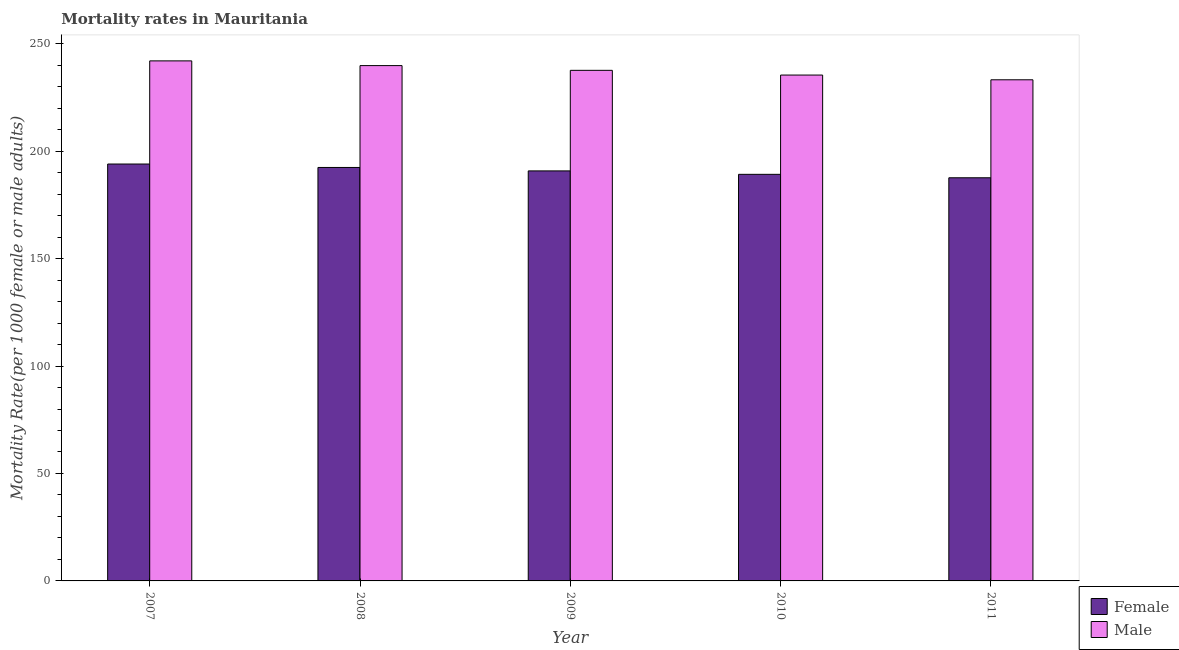How many groups of bars are there?
Offer a very short reply. 5. Are the number of bars per tick equal to the number of legend labels?
Keep it short and to the point. Yes. Are the number of bars on each tick of the X-axis equal?
Your answer should be compact. Yes. How many bars are there on the 1st tick from the left?
Provide a succinct answer. 2. How many bars are there on the 3rd tick from the right?
Ensure brevity in your answer.  2. What is the label of the 2nd group of bars from the left?
Give a very brief answer. 2008. What is the female mortality rate in 2011?
Ensure brevity in your answer.  187.6. Across all years, what is the maximum male mortality rate?
Offer a very short reply. 242. Across all years, what is the minimum male mortality rate?
Your answer should be very brief. 233.2. What is the total male mortality rate in the graph?
Your response must be concise. 1188. What is the difference between the female mortality rate in 2008 and that in 2009?
Your response must be concise. 1.6. What is the difference between the female mortality rate in 2011 and the male mortality rate in 2008?
Your response must be concise. -4.8. What is the average male mortality rate per year?
Your answer should be very brief. 237.6. In the year 2010, what is the difference between the female mortality rate and male mortality rate?
Keep it short and to the point. 0. In how many years, is the male mortality rate greater than 200?
Ensure brevity in your answer.  5. What is the ratio of the male mortality rate in 2009 to that in 2011?
Offer a terse response. 1.02. What is the difference between the highest and the second highest female mortality rate?
Provide a succinct answer. 1.6. What is the difference between the highest and the lowest female mortality rate?
Offer a terse response. 6.4. In how many years, is the male mortality rate greater than the average male mortality rate taken over all years?
Ensure brevity in your answer.  2. What does the 2nd bar from the right in 2011 represents?
Offer a very short reply. Female. How many bars are there?
Provide a succinct answer. 10. Are the values on the major ticks of Y-axis written in scientific E-notation?
Offer a very short reply. No. Where does the legend appear in the graph?
Your answer should be compact. Bottom right. How many legend labels are there?
Offer a very short reply. 2. What is the title of the graph?
Your response must be concise. Mortality rates in Mauritania. Does "Agricultural land" appear as one of the legend labels in the graph?
Make the answer very short. No. What is the label or title of the Y-axis?
Make the answer very short. Mortality Rate(per 1000 female or male adults). What is the Mortality Rate(per 1000 female or male adults) of Female in 2007?
Your answer should be compact. 194. What is the Mortality Rate(per 1000 female or male adults) in Male in 2007?
Give a very brief answer. 242. What is the Mortality Rate(per 1000 female or male adults) in Female in 2008?
Offer a terse response. 192.4. What is the Mortality Rate(per 1000 female or male adults) in Male in 2008?
Provide a short and direct response. 239.8. What is the Mortality Rate(per 1000 female or male adults) of Female in 2009?
Provide a short and direct response. 190.8. What is the Mortality Rate(per 1000 female or male adults) in Male in 2009?
Your answer should be very brief. 237.6. What is the Mortality Rate(per 1000 female or male adults) of Female in 2010?
Make the answer very short. 189.2. What is the Mortality Rate(per 1000 female or male adults) of Male in 2010?
Offer a very short reply. 235.4. What is the Mortality Rate(per 1000 female or male adults) in Female in 2011?
Your answer should be very brief. 187.6. What is the Mortality Rate(per 1000 female or male adults) of Male in 2011?
Offer a terse response. 233.2. Across all years, what is the maximum Mortality Rate(per 1000 female or male adults) of Female?
Keep it short and to the point. 194. Across all years, what is the maximum Mortality Rate(per 1000 female or male adults) in Male?
Your response must be concise. 242. Across all years, what is the minimum Mortality Rate(per 1000 female or male adults) of Female?
Offer a very short reply. 187.6. Across all years, what is the minimum Mortality Rate(per 1000 female or male adults) in Male?
Your answer should be very brief. 233.2. What is the total Mortality Rate(per 1000 female or male adults) of Female in the graph?
Your response must be concise. 954. What is the total Mortality Rate(per 1000 female or male adults) of Male in the graph?
Keep it short and to the point. 1188. What is the difference between the Mortality Rate(per 1000 female or male adults) in Male in 2007 and that in 2008?
Ensure brevity in your answer.  2.2. What is the difference between the Mortality Rate(per 1000 female or male adults) of Male in 2007 and that in 2009?
Make the answer very short. 4.4. What is the difference between the Mortality Rate(per 1000 female or male adults) in Female in 2007 and that in 2010?
Your answer should be compact. 4.8. What is the difference between the Mortality Rate(per 1000 female or male adults) of Male in 2007 and that in 2010?
Your answer should be compact. 6.6. What is the difference between the Mortality Rate(per 1000 female or male adults) of Female in 2007 and that in 2011?
Give a very brief answer. 6.4. What is the difference between the Mortality Rate(per 1000 female or male adults) in Male in 2007 and that in 2011?
Provide a succinct answer. 8.8. What is the difference between the Mortality Rate(per 1000 female or male adults) in Male in 2008 and that in 2009?
Your answer should be very brief. 2.2. What is the difference between the Mortality Rate(per 1000 female or male adults) of Female in 2008 and that in 2010?
Provide a succinct answer. 3.2. What is the difference between the Mortality Rate(per 1000 female or male adults) of Male in 2008 and that in 2010?
Make the answer very short. 4.4. What is the difference between the Mortality Rate(per 1000 female or male adults) of Female in 2008 and that in 2011?
Offer a very short reply. 4.8. What is the difference between the Mortality Rate(per 1000 female or male adults) of Male in 2008 and that in 2011?
Ensure brevity in your answer.  6.6. What is the difference between the Mortality Rate(per 1000 female or male adults) in Male in 2009 and that in 2010?
Make the answer very short. 2.2. What is the difference between the Mortality Rate(per 1000 female or male adults) in Male in 2009 and that in 2011?
Your answer should be compact. 4.4. What is the difference between the Mortality Rate(per 1000 female or male adults) of Male in 2010 and that in 2011?
Your answer should be compact. 2.2. What is the difference between the Mortality Rate(per 1000 female or male adults) in Female in 2007 and the Mortality Rate(per 1000 female or male adults) in Male in 2008?
Keep it short and to the point. -45.8. What is the difference between the Mortality Rate(per 1000 female or male adults) in Female in 2007 and the Mortality Rate(per 1000 female or male adults) in Male in 2009?
Offer a very short reply. -43.6. What is the difference between the Mortality Rate(per 1000 female or male adults) of Female in 2007 and the Mortality Rate(per 1000 female or male adults) of Male in 2010?
Provide a succinct answer. -41.4. What is the difference between the Mortality Rate(per 1000 female or male adults) of Female in 2007 and the Mortality Rate(per 1000 female or male adults) of Male in 2011?
Your response must be concise. -39.2. What is the difference between the Mortality Rate(per 1000 female or male adults) in Female in 2008 and the Mortality Rate(per 1000 female or male adults) in Male in 2009?
Provide a succinct answer. -45.2. What is the difference between the Mortality Rate(per 1000 female or male adults) of Female in 2008 and the Mortality Rate(per 1000 female or male adults) of Male in 2010?
Your answer should be compact. -43. What is the difference between the Mortality Rate(per 1000 female or male adults) in Female in 2008 and the Mortality Rate(per 1000 female or male adults) in Male in 2011?
Your answer should be very brief. -40.8. What is the difference between the Mortality Rate(per 1000 female or male adults) in Female in 2009 and the Mortality Rate(per 1000 female or male adults) in Male in 2010?
Your answer should be compact. -44.6. What is the difference between the Mortality Rate(per 1000 female or male adults) in Female in 2009 and the Mortality Rate(per 1000 female or male adults) in Male in 2011?
Offer a terse response. -42.4. What is the difference between the Mortality Rate(per 1000 female or male adults) of Female in 2010 and the Mortality Rate(per 1000 female or male adults) of Male in 2011?
Keep it short and to the point. -44. What is the average Mortality Rate(per 1000 female or male adults) of Female per year?
Provide a succinct answer. 190.8. What is the average Mortality Rate(per 1000 female or male adults) of Male per year?
Ensure brevity in your answer.  237.6. In the year 2007, what is the difference between the Mortality Rate(per 1000 female or male adults) of Female and Mortality Rate(per 1000 female or male adults) of Male?
Give a very brief answer. -48. In the year 2008, what is the difference between the Mortality Rate(per 1000 female or male adults) of Female and Mortality Rate(per 1000 female or male adults) of Male?
Provide a short and direct response. -47.4. In the year 2009, what is the difference between the Mortality Rate(per 1000 female or male adults) in Female and Mortality Rate(per 1000 female or male adults) in Male?
Your answer should be very brief. -46.8. In the year 2010, what is the difference between the Mortality Rate(per 1000 female or male adults) of Female and Mortality Rate(per 1000 female or male adults) of Male?
Your answer should be very brief. -46.2. In the year 2011, what is the difference between the Mortality Rate(per 1000 female or male adults) in Female and Mortality Rate(per 1000 female or male adults) in Male?
Provide a succinct answer. -45.6. What is the ratio of the Mortality Rate(per 1000 female or male adults) of Female in 2007 to that in 2008?
Offer a terse response. 1.01. What is the ratio of the Mortality Rate(per 1000 female or male adults) in Male in 2007 to that in 2008?
Offer a very short reply. 1.01. What is the ratio of the Mortality Rate(per 1000 female or male adults) in Female in 2007 to that in 2009?
Your answer should be very brief. 1.02. What is the ratio of the Mortality Rate(per 1000 female or male adults) in Male in 2007 to that in 2009?
Offer a very short reply. 1.02. What is the ratio of the Mortality Rate(per 1000 female or male adults) in Female in 2007 to that in 2010?
Ensure brevity in your answer.  1.03. What is the ratio of the Mortality Rate(per 1000 female or male adults) of Male in 2007 to that in 2010?
Give a very brief answer. 1.03. What is the ratio of the Mortality Rate(per 1000 female or male adults) in Female in 2007 to that in 2011?
Your response must be concise. 1.03. What is the ratio of the Mortality Rate(per 1000 female or male adults) in Male in 2007 to that in 2011?
Your response must be concise. 1.04. What is the ratio of the Mortality Rate(per 1000 female or male adults) of Female in 2008 to that in 2009?
Provide a short and direct response. 1.01. What is the ratio of the Mortality Rate(per 1000 female or male adults) of Male in 2008 to that in 2009?
Provide a succinct answer. 1.01. What is the ratio of the Mortality Rate(per 1000 female or male adults) in Female in 2008 to that in 2010?
Offer a very short reply. 1.02. What is the ratio of the Mortality Rate(per 1000 female or male adults) in Male in 2008 to that in 2010?
Keep it short and to the point. 1.02. What is the ratio of the Mortality Rate(per 1000 female or male adults) of Female in 2008 to that in 2011?
Your response must be concise. 1.03. What is the ratio of the Mortality Rate(per 1000 female or male adults) of Male in 2008 to that in 2011?
Provide a succinct answer. 1.03. What is the ratio of the Mortality Rate(per 1000 female or male adults) of Female in 2009 to that in 2010?
Offer a terse response. 1.01. What is the ratio of the Mortality Rate(per 1000 female or male adults) of Male in 2009 to that in 2010?
Your answer should be compact. 1.01. What is the ratio of the Mortality Rate(per 1000 female or male adults) in Female in 2009 to that in 2011?
Offer a very short reply. 1.02. What is the ratio of the Mortality Rate(per 1000 female or male adults) in Male in 2009 to that in 2011?
Your answer should be compact. 1.02. What is the ratio of the Mortality Rate(per 1000 female or male adults) of Female in 2010 to that in 2011?
Ensure brevity in your answer.  1.01. What is the ratio of the Mortality Rate(per 1000 female or male adults) of Male in 2010 to that in 2011?
Ensure brevity in your answer.  1.01. What is the difference between the highest and the lowest Mortality Rate(per 1000 female or male adults) of Male?
Provide a succinct answer. 8.8. 